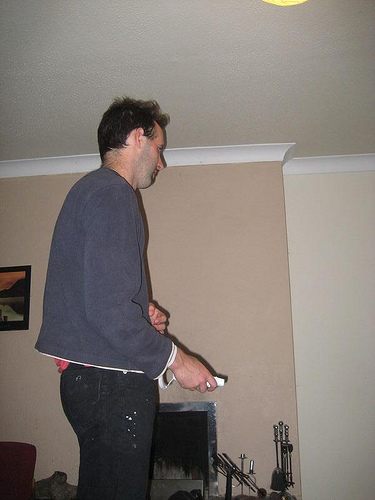<image>What pattern is on the man's shirt? I am not sure what pattern is on the man's shirt. It could be solid or striped. What pattern is on the man's shirt? I don't know what pattern is on the man's shirt. It can be either solids or stripes. 